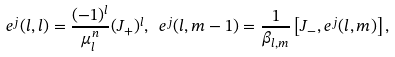Convert formula to latex. <formula><loc_0><loc_0><loc_500><loc_500>e ^ { j } ( l , l ) = \frac { ( - 1 ) ^ { l } } { \mu ^ { n } _ { l } } ( J _ { + } ) ^ { l } , \ e ^ { j } ( l , m - 1 ) = \frac { 1 } { \beta _ { l , m } } \left [ J _ { - } , e ^ { j } ( l , m ) \right ] ,</formula> 